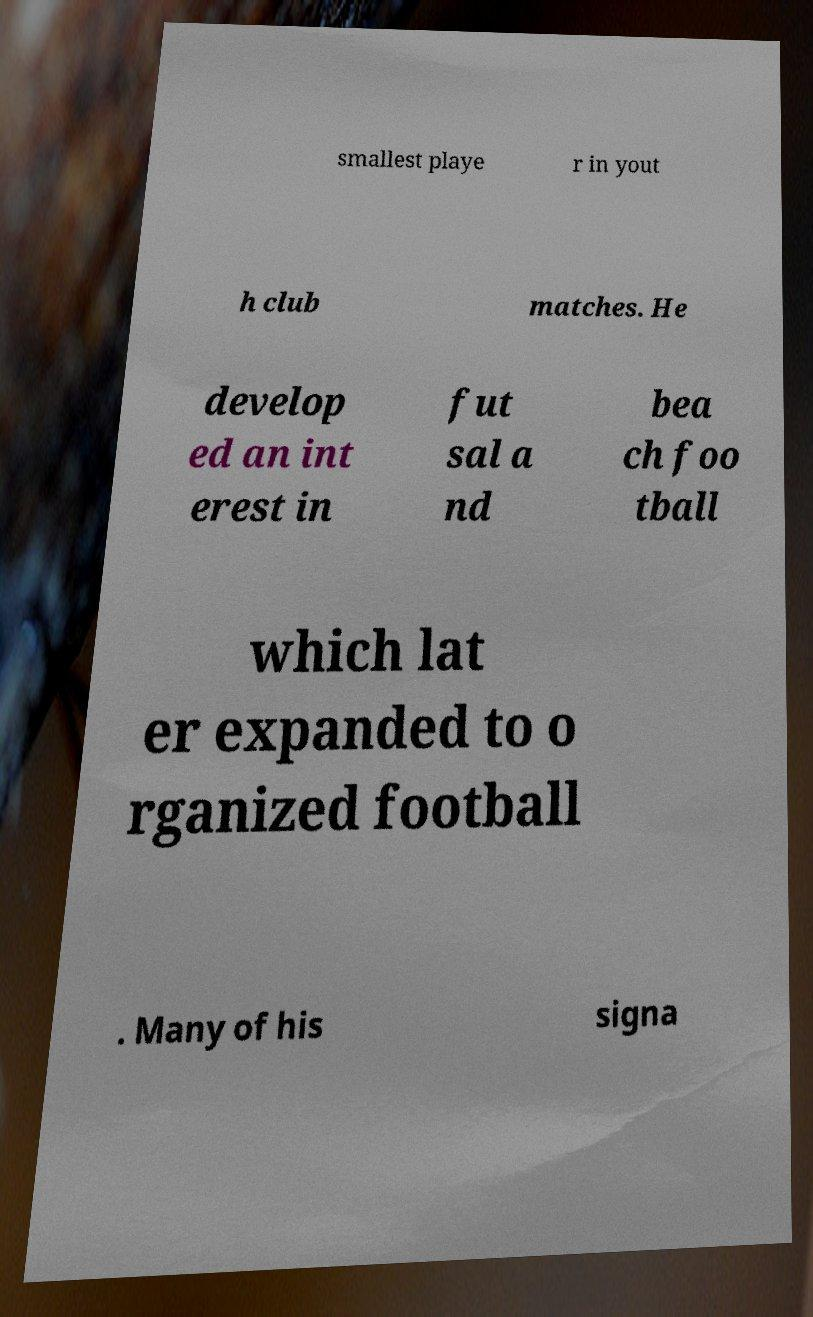Please identify and transcribe the text found in this image. smallest playe r in yout h club matches. He develop ed an int erest in fut sal a nd bea ch foo tball which lat er expanded to o rganized football . Many of his signa 